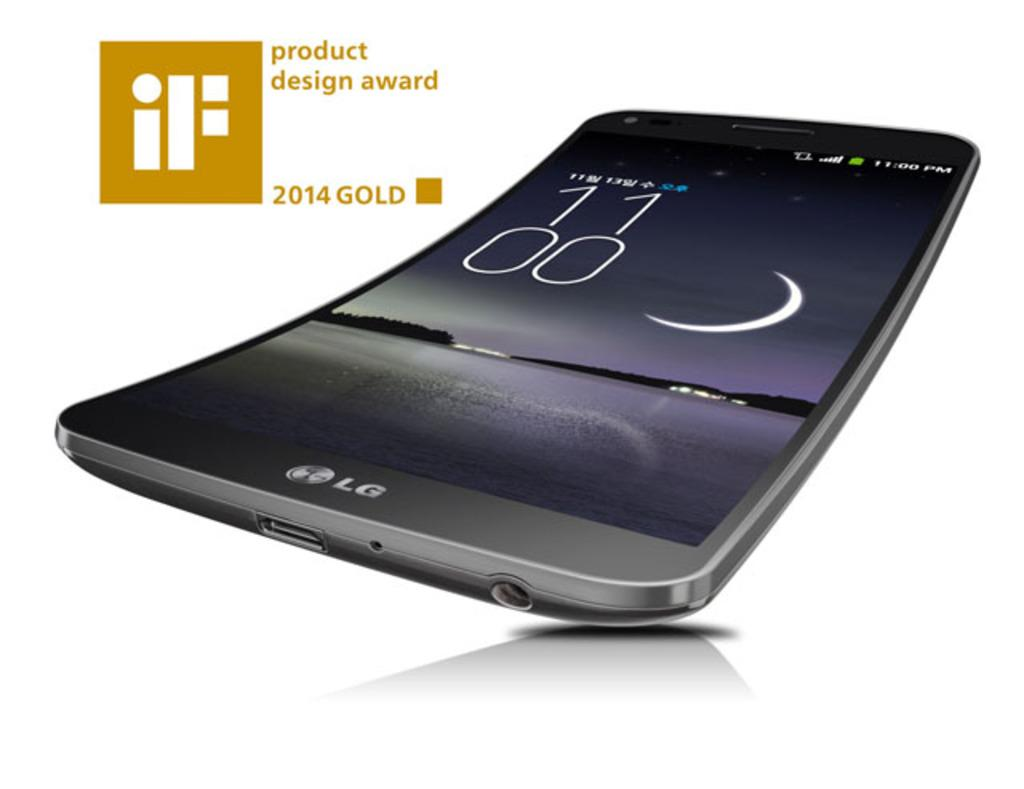<image>
Give a short and clear explanation of the subsequent image. An LG phone is the recipient of the iF product design award. 